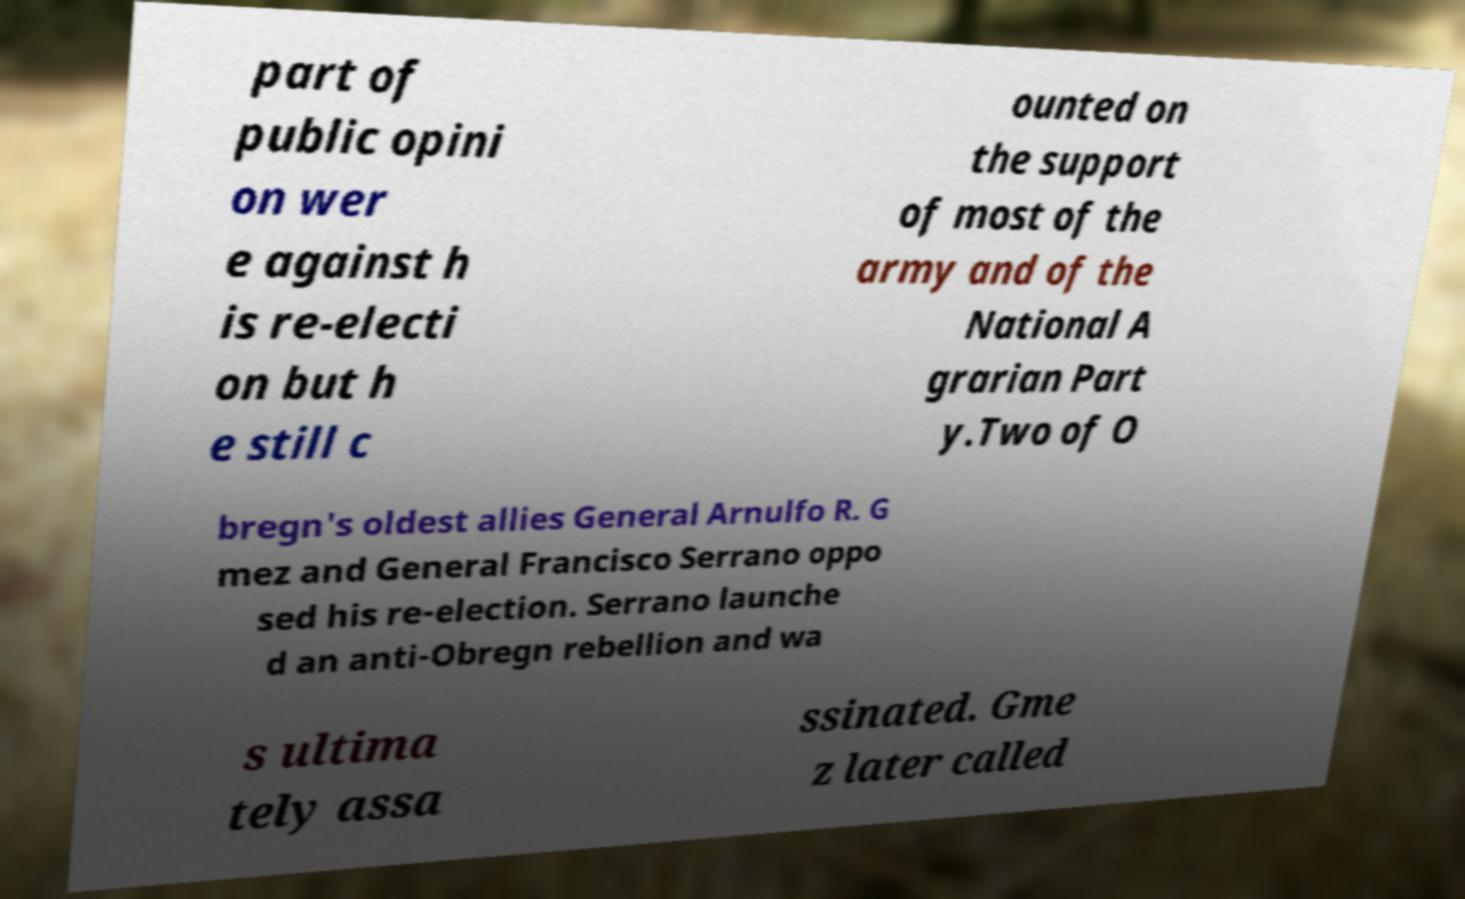There's text embedded in this image that I need extracted. Can you transcribe it verbatim? part of public opini on wer e against h is re-electi on but h e still c ounted on the support of most of the army and of the National A grarian Part y.Two of O bregn's oldest allies General Arnulfo R. G mez and General Francisco Serrano oppo sed his re-election. Serrano launche d an anti-Obregn rebellion and wa s ultima tely assa ssinated. Gme z later called 